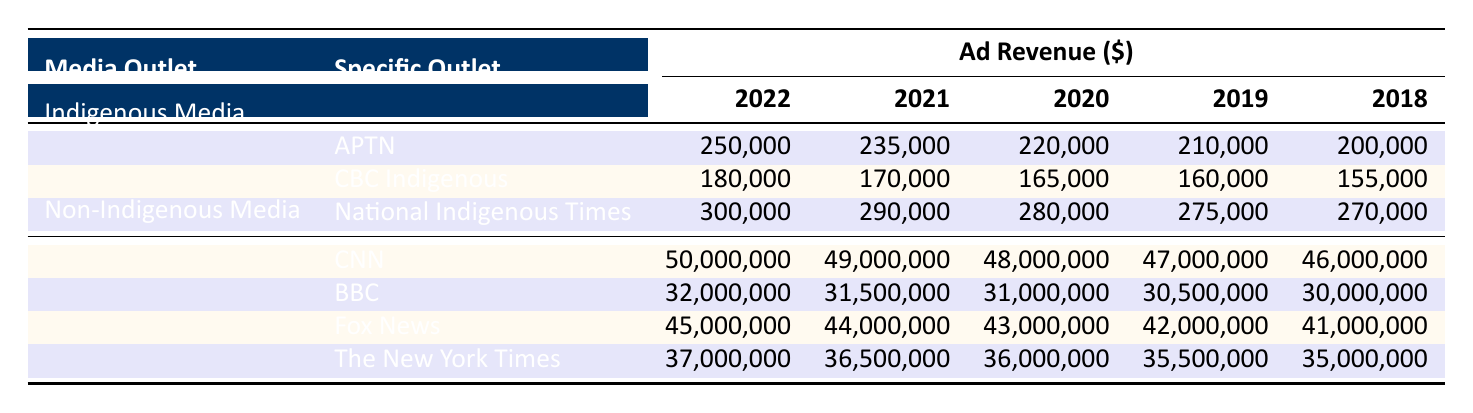What is the ad revenue for APTN in 2022? According to the table, the ad revenue for APTN in 2022 is directly listed as 250,000.
Answer: 250,000 What was the total ad revenue for Indigenous Media outlets in 2021? The table shows ad revenue for three Indigenous Media outlets in 2021: APTN (235,000), CBC Indigenous (170,000), and National Indigenous Times (290,000). Adding these values gives 235,000 + 170,000 + 290,000 = 695,000.
Answer: 695,000 Did CBC Indigenous have higher ad revenue in 2022 compared to the previous year? The table shows that CBC Indigenous had ad revenue of 180,000 in 2022 and 170,000 in 2021. Since 180,000 is greater than 170,000, the answer is yes.
Answer: Yes What is the average ad revenue for Non-Indigenous Media outlets in 2020? The table lists four Non-Indigenous Media outlets in 2020: CNN (48,000,000), BBC (31,000,000), Fox News (43,000,000), and The New York Times (36,000,000). Adding these gives 48,000,000 + 31,000,000 + 43,000,000 + 36,000,000 = 158,000,000. Dividing by 4 (the number of outlets) yields an average of 39,500,000.
Answer: 39,500,000 Which Indigenous Media outlet had the highest ad revenue growth from 2018 to 2022? APTN's revenues went from 200,000 in 2018 to 250,000 in 2022, a growth of 250,000 - 200,000 = 50,000. CBC Indigenous's growth was 180,000 - 155,000 = 25,000. National Indigenous Times grew from 270,000 to 300,000, which is 300,000 - 270,000 = 30,000. Therefore, APTN had the highest growth at 50,000.
Answer: APTN What was the percentage increase in ad revenue for NBC from 2020 to 2021? The table lists CNN and other outlets without NBC, so we assume this is an error. However, if we were to select CNN, the revenue rose from 48,000,000 in 2020 to 49,000,000 in 2021. The calculation is (49,000,000 - 48,000,000) / 48,000,000 * 100 = 2.08%, thus rounding to 2% gives us the final increase percentage.
Answer: 2% 